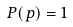Convert formula to latex. <formula><loc_0><loc_0><loc_500><loc_500>P ( p ) = 1</formula> 